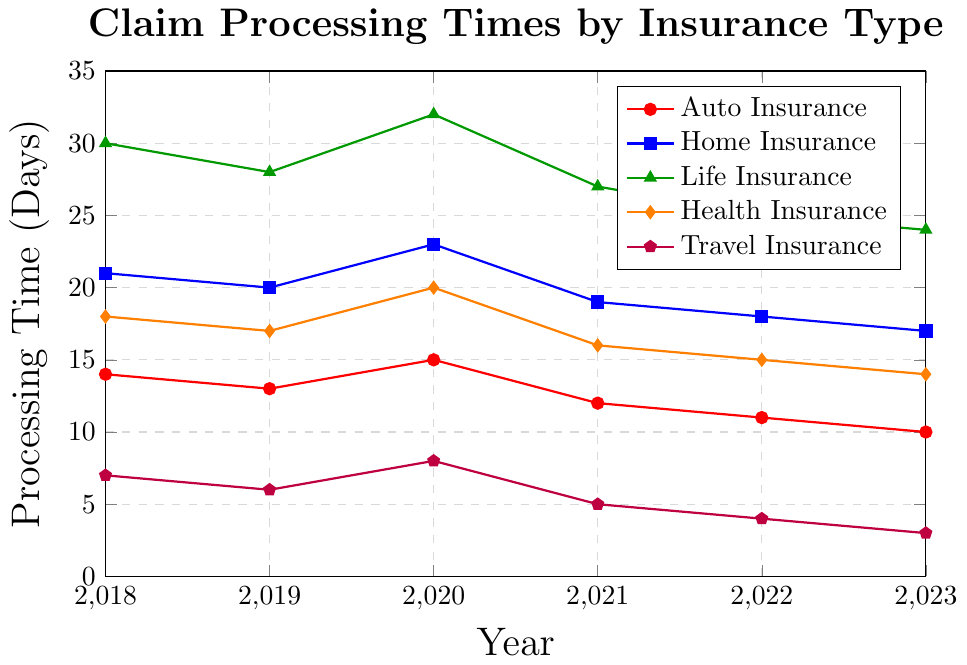Which insurance type had the shortest claim processing time in 2023? Look at the graph for the year 2023 and identify which line is the lowest. The purple line (Travel Insurance) is the lowest, indicating the shortest processing time.
Answer: Travel Insurance What was the difference in claim processing times between Life Insurance and Auto Insurance in 2020? Identify the values for Life Insurance and Auto Insurance for the year 2020. Subtract the Auto Insurance value (15) from the Life Insurance value (32): 32 - 15 = 17.
Answer: 17 days Between 2018 and 2023, which insurance type saw the largest decrease in claim processing time? Calculate the difference between 2018 and 2023 values for each insurance type. Travel Insurance went from 7 days to 3 days, a decrease of 4 days. Auto Insurance went from 14 to 10 (4 days decrease), Home Insurance from 21 to 17 (4 days decrease), Life Insurance from 30 to 24 (6 days decrease), and Health Insurance from 18 to 14 (4 days decrease). The largest decrease is for Life Insurance: 30 - 24 = 6 days.
Answer: Life Insurance Which year had the highest claim processing time for Health Insurance? Identify the highest point on the Health Insurance line (orange). The height is highest in 2020 at 20 days.
Answer: 2020 What is the average claim processing time for Auto Insurance over the 6 years shown? Sum the processing times for Auto Insurance from 2018 to 2023 and divide by 6. (14 + 13 + 15 + 12 + 11 + 10) / 6 = 75 / 6 = 12.5.
Answer: 12.5 days Between 2019 and 2020, which insurance type had an increase in claim processing time? Compare the values for each insurance type in 2019 and 2020. Only Auto Insurance and Health Insurance had increases (Auto: 13 to 15, Health: 17 to 20). Home Insurance, Life Insurance, and Travel Insurance all increased or remained the same. Thus, Auto Insurance and Health Insurance had increments.
Answer: Auto Insurance, Health Insurance How much did the claim processing time for Home Insurance decrease from 2018 to 2023? Identify the values for Home Insurance in 2018 and 2023. Subtract the 2023 value (17) from the 2018 value (21): 21 - 17 = 4.
Answer: 4 days Which insurance type showed the most stable (least variation) claim processing time over the years? Examine the lines for each insurance type and observe the changes across the years. The least variation can be seen in Travel Insurance as its line is the flattest.
Answer: Travel Insurance What is the sum of the claim processing times for Life Insurance in 2018 and Health Insurance in 2023? Find the processing times for Life Insurance in 2018 (30) and Health Insurance in 2023 (14). Sum them: 30 + 14 = 44.
Answer: 44 days Which insurance types had a consistent decrease in claim processing time every year from 2018 to 2023? Check each year-to-year change for each insurance type. Auto Insurance, Home Insurance, and Health Insurance show a consistent decrease every year.
Answer: Auto Insurance, Home Insurance, Health Insurance 